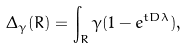<formula> <loc_0><loc_0><loc_500><loc_500>\Delta _ { \gamma } ( R ) = \int _ { R } \gamma ( 1 - e ^ { t D \lambda } ) ,</formula> 